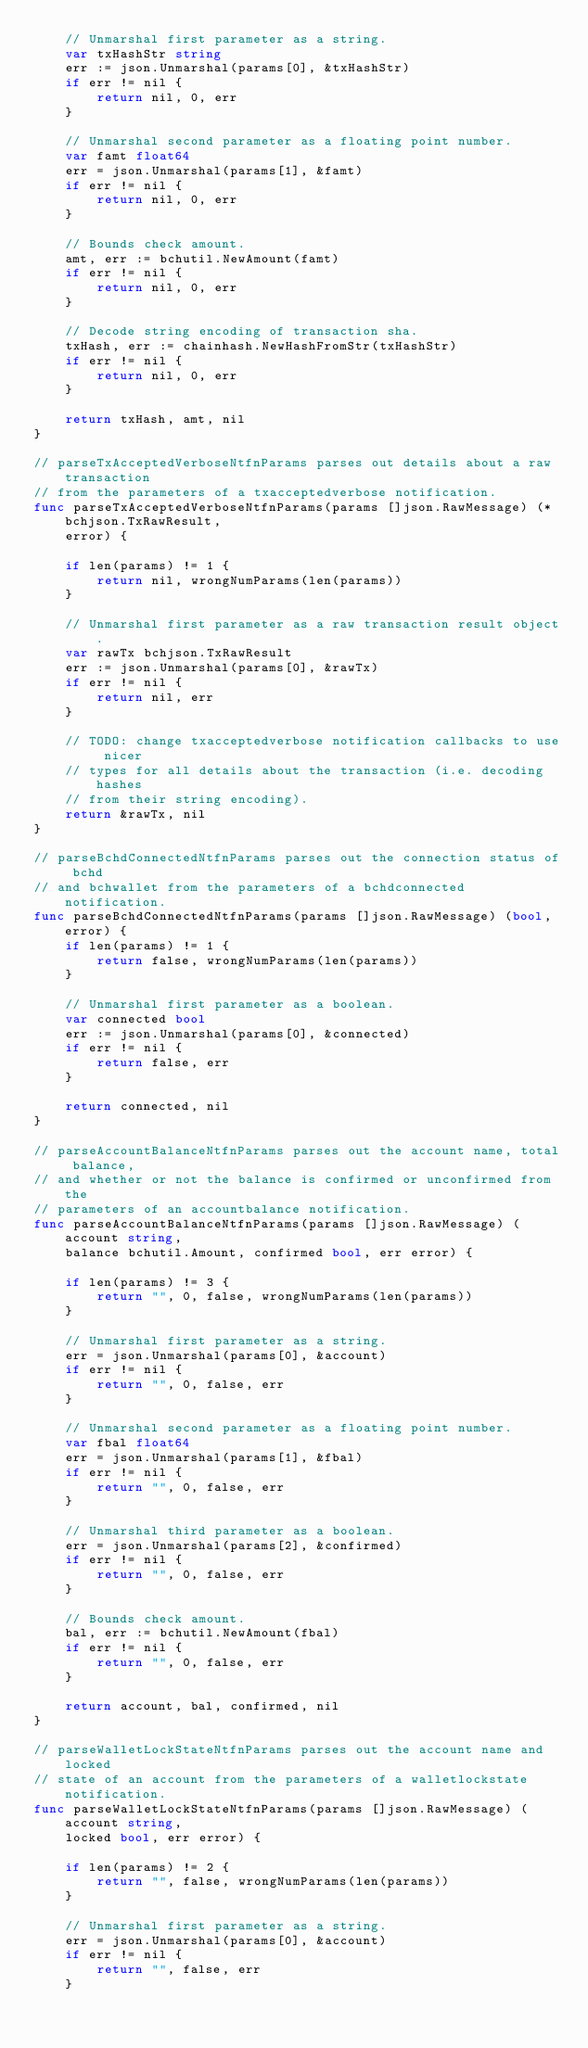<code> <loc_0><loc_0><loc_500><loc_500><_Go_>	// Unmarshal first parameter as a string.
	var txHashStr string
	err := json.Unmarshal(params[0], &txHashStr)
	if err != nil {
		return nil, 0, err
	}

	// Unmarshal second parameter as a floating point number.
	var famt float64
	err = json.Unmarshal(params[1], &famt)
	if err != nil {
		return nil, 0, err
	}

	// Bounds check amount.
	amt, err := bchutil.NewAmount(famt)
	if err != nil {
		return nil, 0, err
	}

	// Decode string encoding of transaction sha.
	txHash, err := chainhash.NewHashFromStr(txHashStr)
	if err != nil {
		return nil, 0, err
	}

	return txHash, amt, nil
}

// parseTxAcceptedVerboseNtfnParams parses out details about a raw transaction
// from the parameters of a txacceptedverbose notification.
func parseTxAcceptedVerboseNtfnParams(params []json.RawMessage) (*bchjson.TxRawResult,
	error) {

	if len(params) != 1 {
		return nil, wrongNumParams(len(params))
	}

	// Unmarshal first parameter as a raw transaction result object.
	var rawTx bchjson.TxRawResult
	err := json.Unmarshal(params[0], &rawTx)
	if err != nil {
		return nil, err
	}

	// TODO: change txacceptedverbose notification callbacks to use nicer
	// types for all details about the transaction (i.e. decoding hashes
	// from their string encoding).
	return &rawTx, nil
}

// parseBchdConnectedNtfnParams parses out the connection status of bchd
// and bchwallet from the parameters of a bchdconnected notification.
func parseBchdConnectedNtfnParams(params []json.RawMessage) (bool, error) {
	if len(params) != 1 {
		return false, wrongNumParams(len(params))
	}

	// Unmarshal first parameter as a boolean.
	var connected bool
	err := json.Unmarshal(params[0], &connected)
	if err != nil {
		return false, err
	}

	return connected, nil
}

// parseAccountBalanceNtfnParams parses out the account name, total balance,
// and whether or not the balance is confirmed or unconfirmed from the
// parameters of an accountbalance notification.
func parseAccountBalanceNtfnParams(params []json.RawMessage) (account string,
	balance bchutil.Amount, confirmed bool, err error) {

	if len(params) != 3 {
		return "", 0, false, wrongNumParams(len(params))
	}

	// Unmarshal first parameter as a string.
	err = json.Unmarshal(params[0], &account)
	if err != nil {
		return "", 0, false, err
	}

	// Unmarshal second parameter as a floating point number.
	var fbal float64
	err = json.Unmarshal(params[1], &fbal)
	if err != nil {
		return "", 0, false, err
	}

	// Unmarshal third parameter as a boolean.
	err = json.Unmarshal(params[2], &confirmed)
	if err != nil {
		return "", 0, false, err
	}

	// Bounds check amount.
	bal, err := bchutil.NewAmount(fbal)
	if err != nil {
		return "", 0, false, err
	}

	return account, bal, confirmed, nil
}

// parseWalletLockStateNtfnParams parses out the account name and locked
// state of an account from the parameters of a walletlockstate notification.
func parseWalletLockStateNtfnParams(params []json.RawMessage) (account string,
	locked bool, err error) {

	if len(params) != 2 {
		return "", false, wrongNumParams(len(params))
	}

	// Unmarshal first parameter as a string.
	err = json.Unmarshal(params[0], &account)
	if err != nil {
		return "", false, err
	}
</code> 